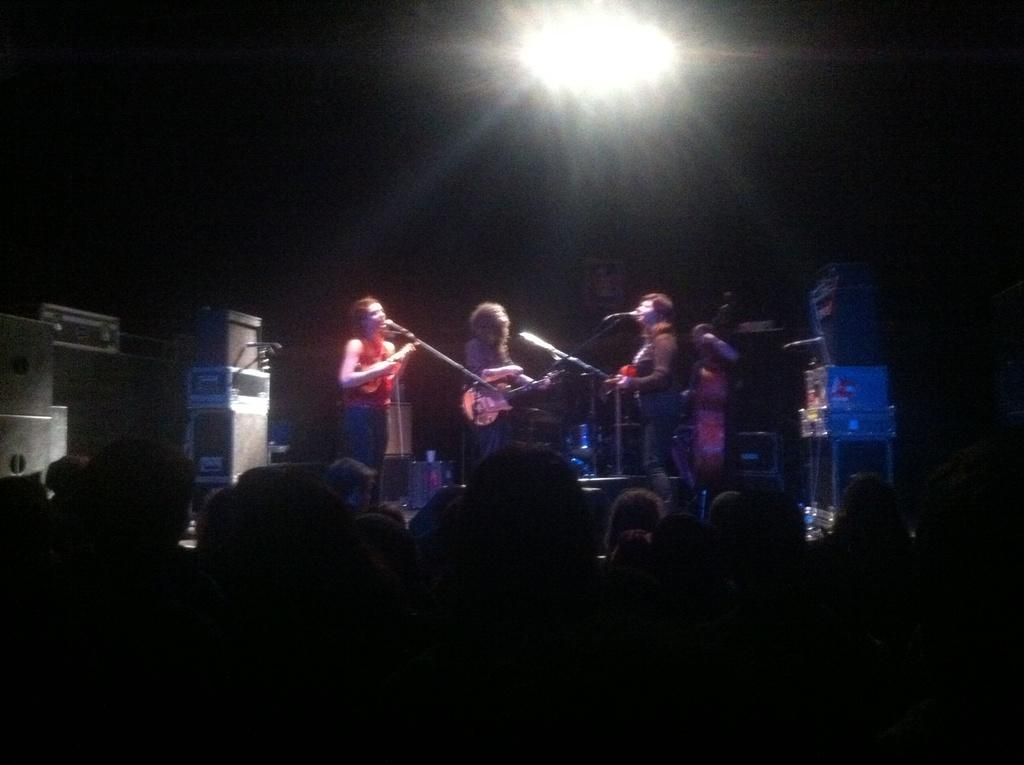How many people are in the image? There are three people in the image. What are the three people doing in the image? The three people are standing in front of a microphone, and each of them is holding a musical instrument. Are there any other people in the image besides the musicians? Yes, there are people standing in front of the musicians, listening to them. What type of pipe can be seen in the hands of one of the musicians? There is no pipe present in the image; each of the musicians is holding a musical instrument. How does the emotion of hate manifest in the image? The emotion of hate is not present in the image; the people in the image appear to be enjoying the music. 